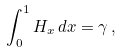<formula> <loc_0><loc_0><loc_500><loc_500>\int _ { 0 } ^ { 1 } H _ { x } \, d x = \gamma \, ,</formula> 